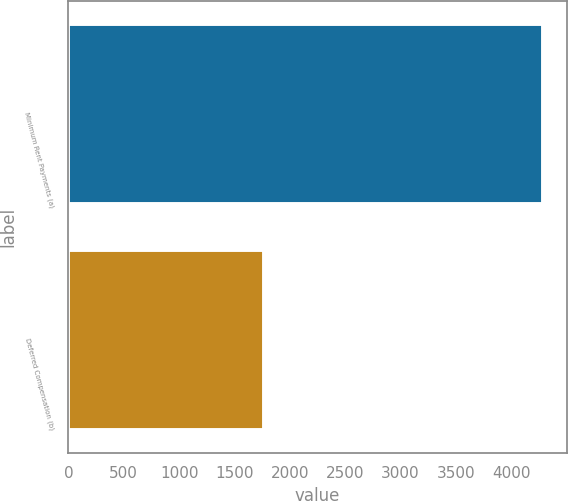Convert chart. <chart><loc_0><loc_0><loc_500><loc_500><bar_chart><fcel>Minimum Rent Payments (a)<fcel>Deferred Compensation (b)<nl><fcel>4285<fcel>1770<nl></chart> 